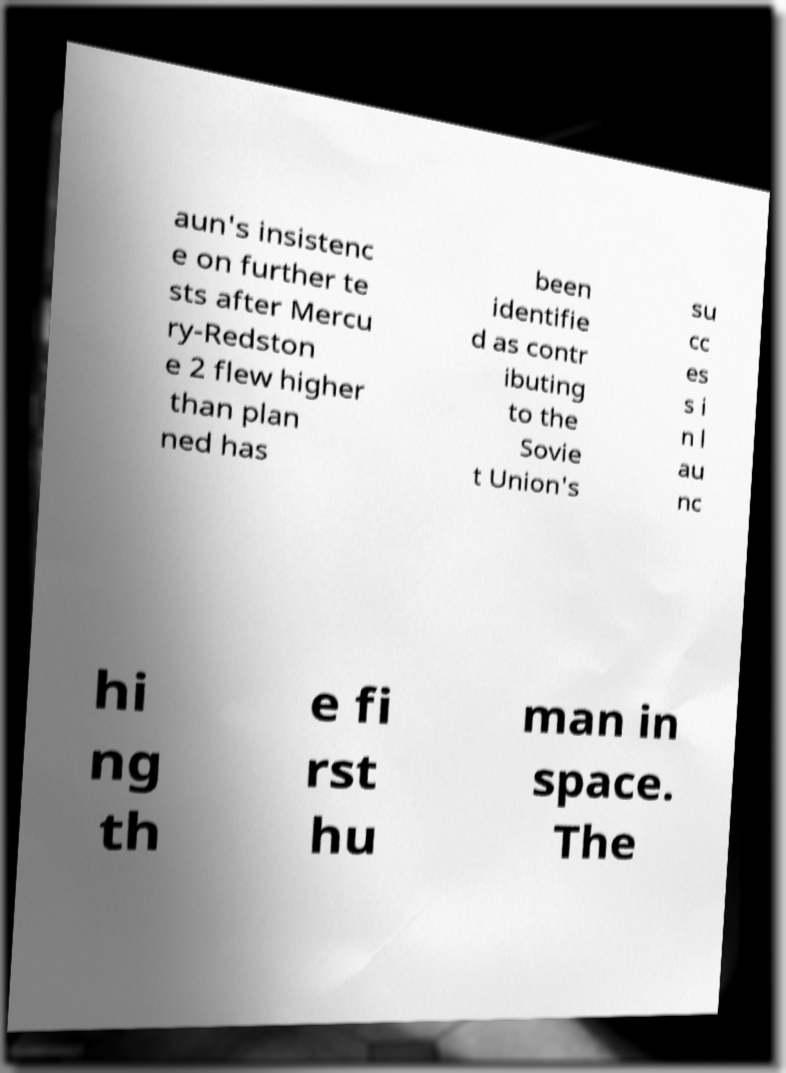What messages or text are displayed in this image? I need them in a readable, typed format. aun's insistenc e on further te sts after Mercu ry-Redston e 2 flew higher than plan ned has been identifie d as contr ibuting to the Sovie t Union's su cc es s i n l au nc hi ng th e fi rst hu man in space. The 